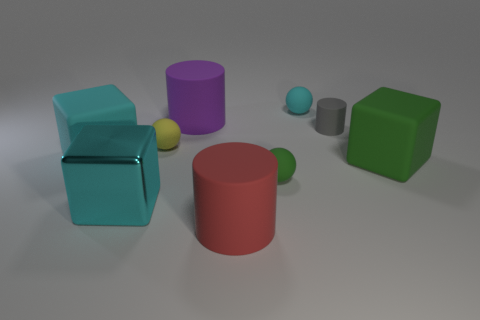Add 1 cyan rubber balls. How many objects exist? 10 Subtract all blocks. How many objects are left? 6 Subtract all tiny cyan shiny blocks. Subtract all red matte objects. How many objects are left? 8 Add 6 green spheres. How many green spheres are left? 7 Add 5 small matte cylinders. How many small matte cylinders exist? 6 Subtract 0 brown blocks. How many objects are left? 9 